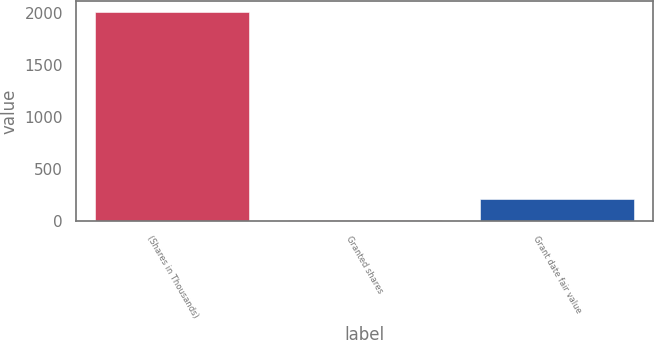Convert chart. <chart><loc_0><loc_0><loc_500><loc_500><bar_chart><fcel>(Shares in Thousands)<fcel>Granted shares<fcel>Grant date fair value<nl><fcel>2017<fcel>15<fcel>215.2<nl></chart> 